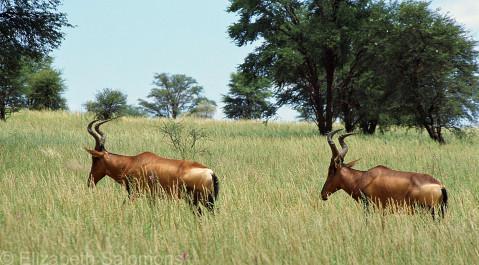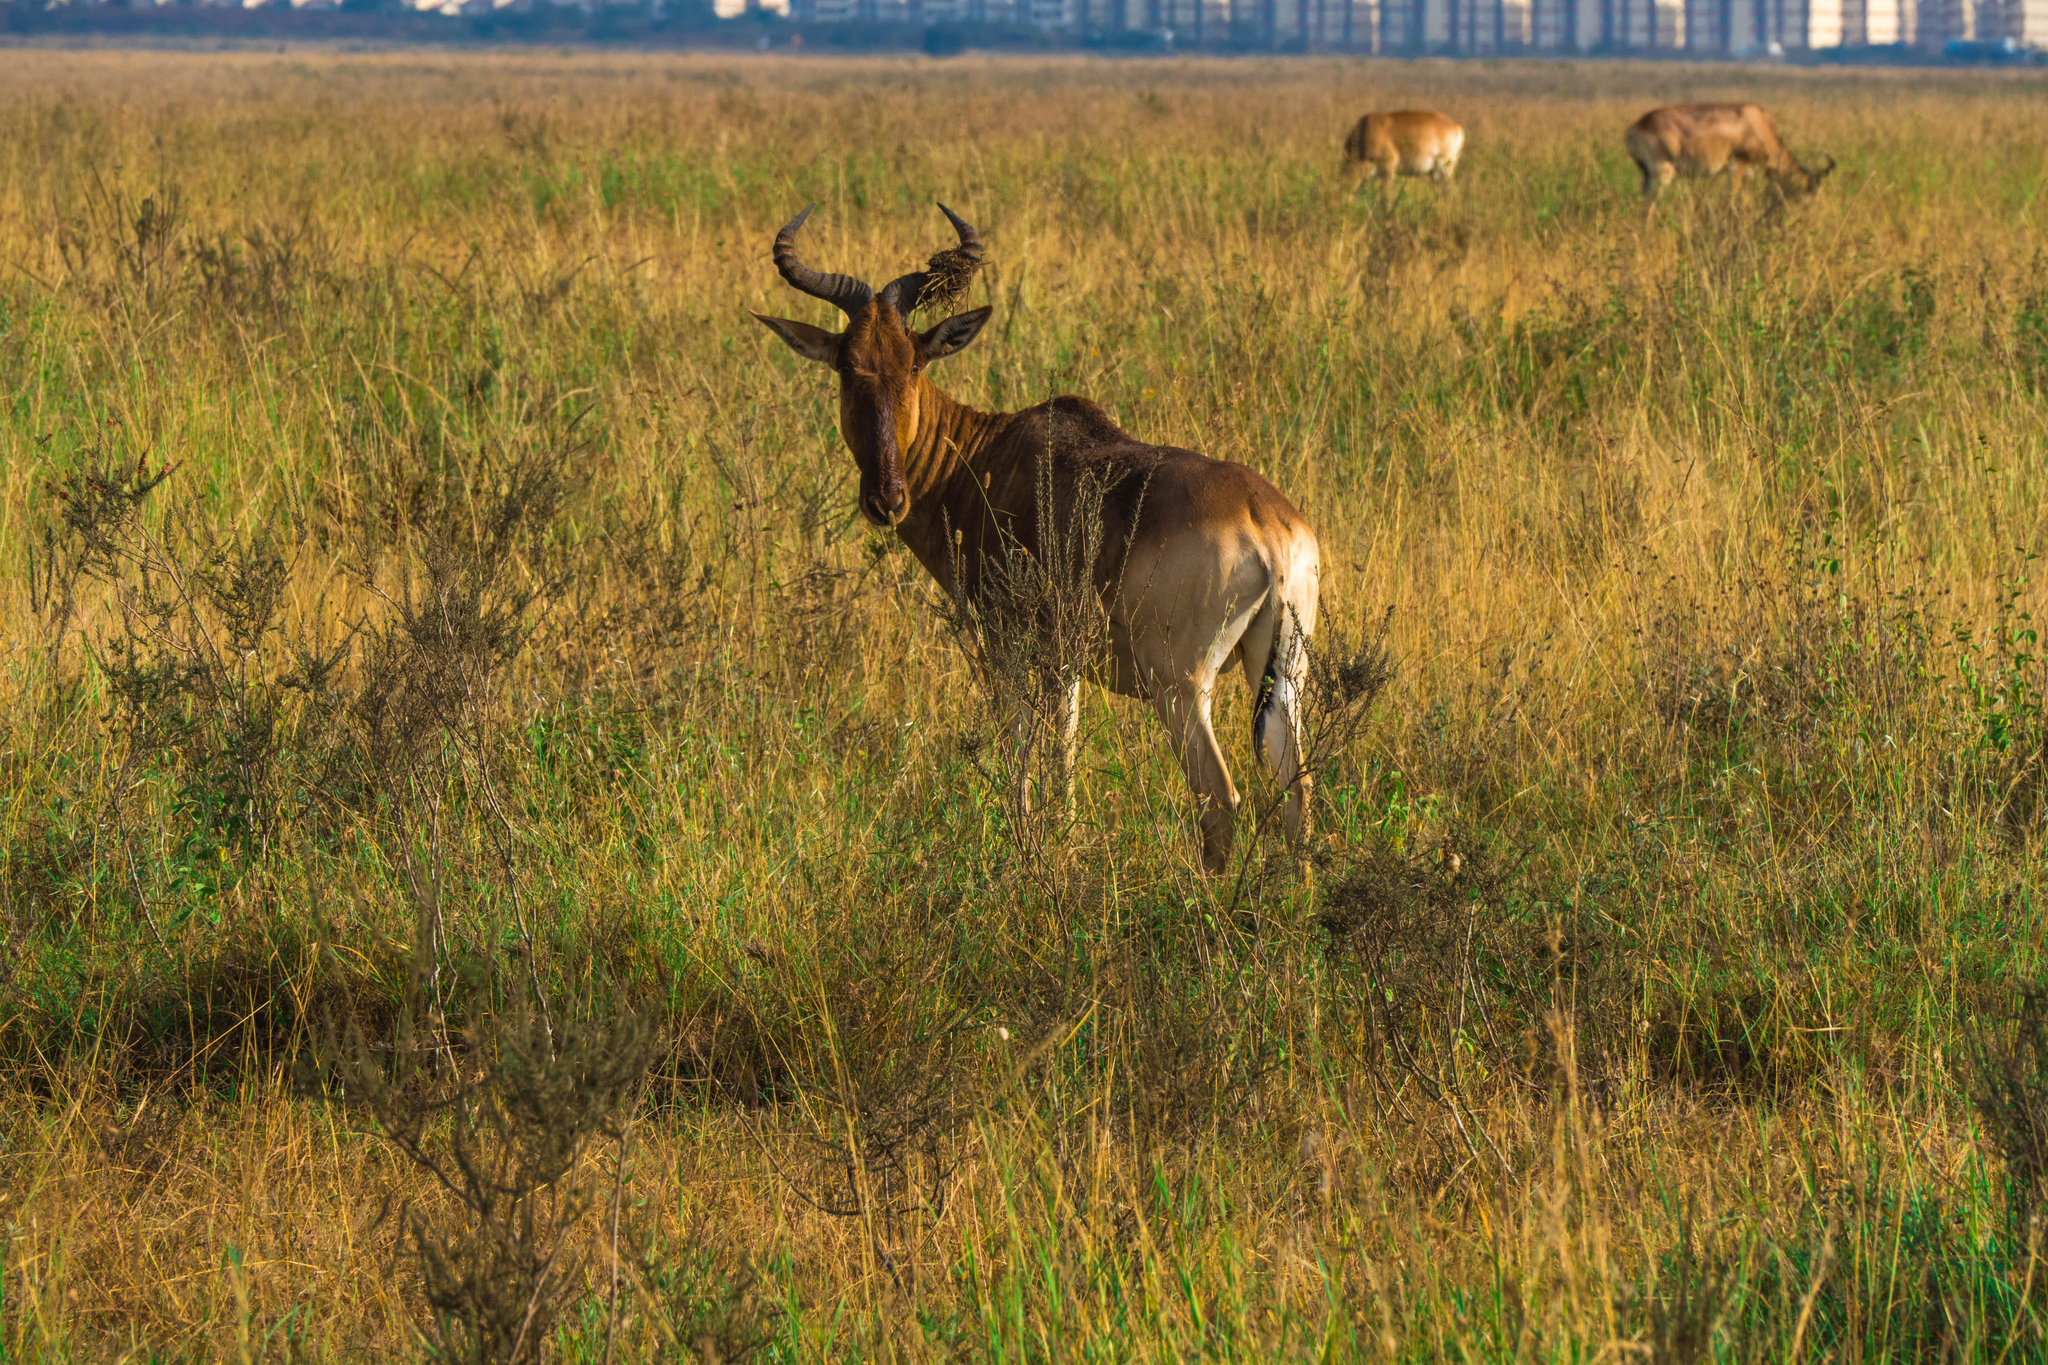The first image is the image on the left, the second image is the image on the right. For the images shown, is this caption "The left image features more antelopes in the foreground than the right image." true? Answer yes or no. Yes. 